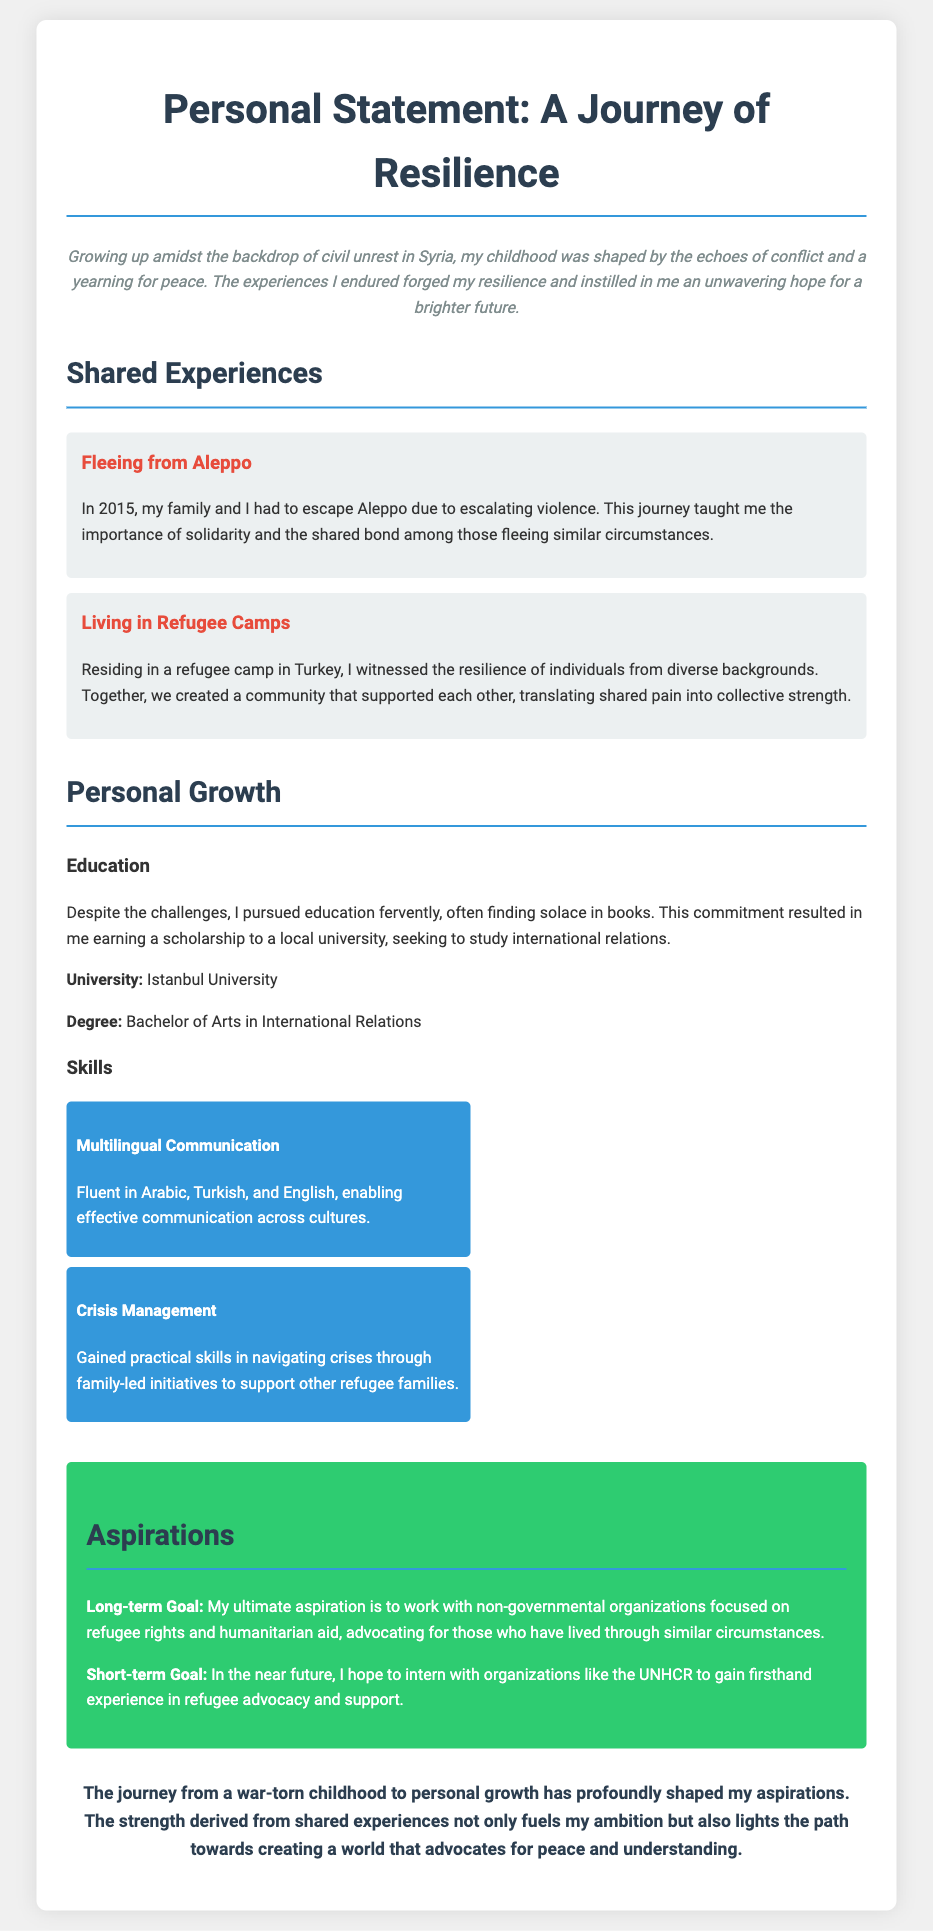What year did the author flee from Aleppo? The document states that the author fled from Aleppo in 2015.
Answer: 2015 What degree is the author pursuing? The author is pursuing a Bachelor of Arts in International Relations as mentioned in the education section.
Answer: Bachelor of Arts in International Relations What is the ultimate aspiration of the author? The document mentions that the author's ultimate aspiration is to work with non-governmental organizations focused on refugee rights and humanitarian aid.
Answer: Work with non-governmental organizations Which university is mentioned in the document? The document explicitly states that Istanbul University is the university the author is attending.
Answer: Istanbul University Which languages can the author communicate in? The document lists Arabic, Turkish, and English as the languages the author is fluent in.
Answer: Arabic, Turkish, and English Why did the author find solace in books? The author faced challenges during their childhood and often turned to books for comfort, as stated in the personal growth section.
Answer: To find solace What was created within the refugee camp according to the document? The author describes that a community was created among individuals to support each other in the refugee camp.
Answer: A community What skill is related to managing crises mentioned in the document? The skill mentioned is "Crisis Management," which the author gained through family-led initiatives.
Answer: Crisis Management 